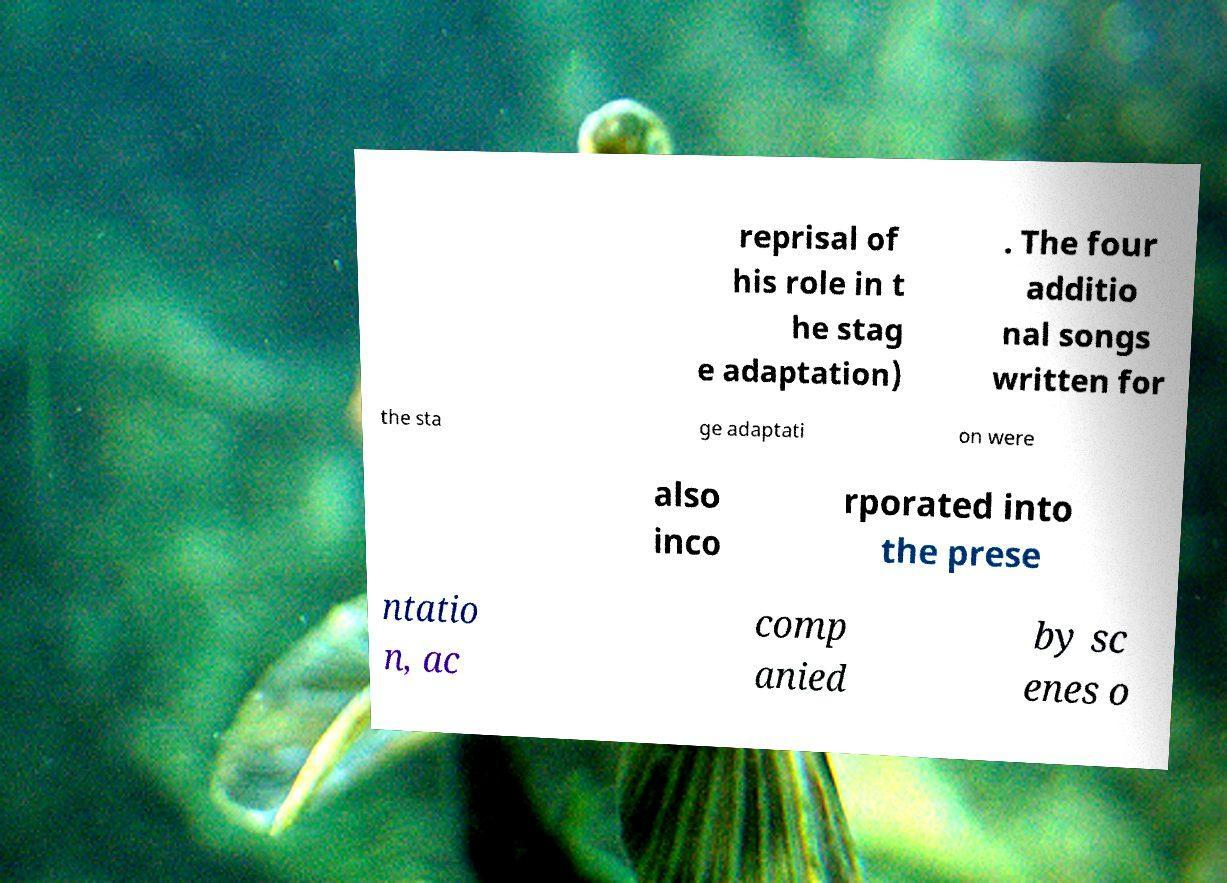Can you read and provide the text displayed in the image?This photo seems to have some interesting text. Can you extract and type it out for me? reprisal of his role in t he stag e adaptation) . The four additio nal songs written for the sta ge adaptati on were also inco rporated into the prese ntatio n, ac comp anied by sc enes o 